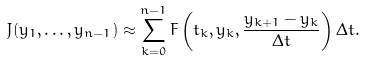Convert formula to latex. <formula><loc_0><loc_0><loc_500><loc_500>J ( y _ { 1 } , \dots , y _ { n - 1 } ) \approx \sum _ { k = 0 } ^ { n - 1 } F \left ( t _ { k } , y _ { k } , { \frac { y _ { k + 1 } - y _ { k } } { \Delta t } } \right ) \Delta t .</formula> 